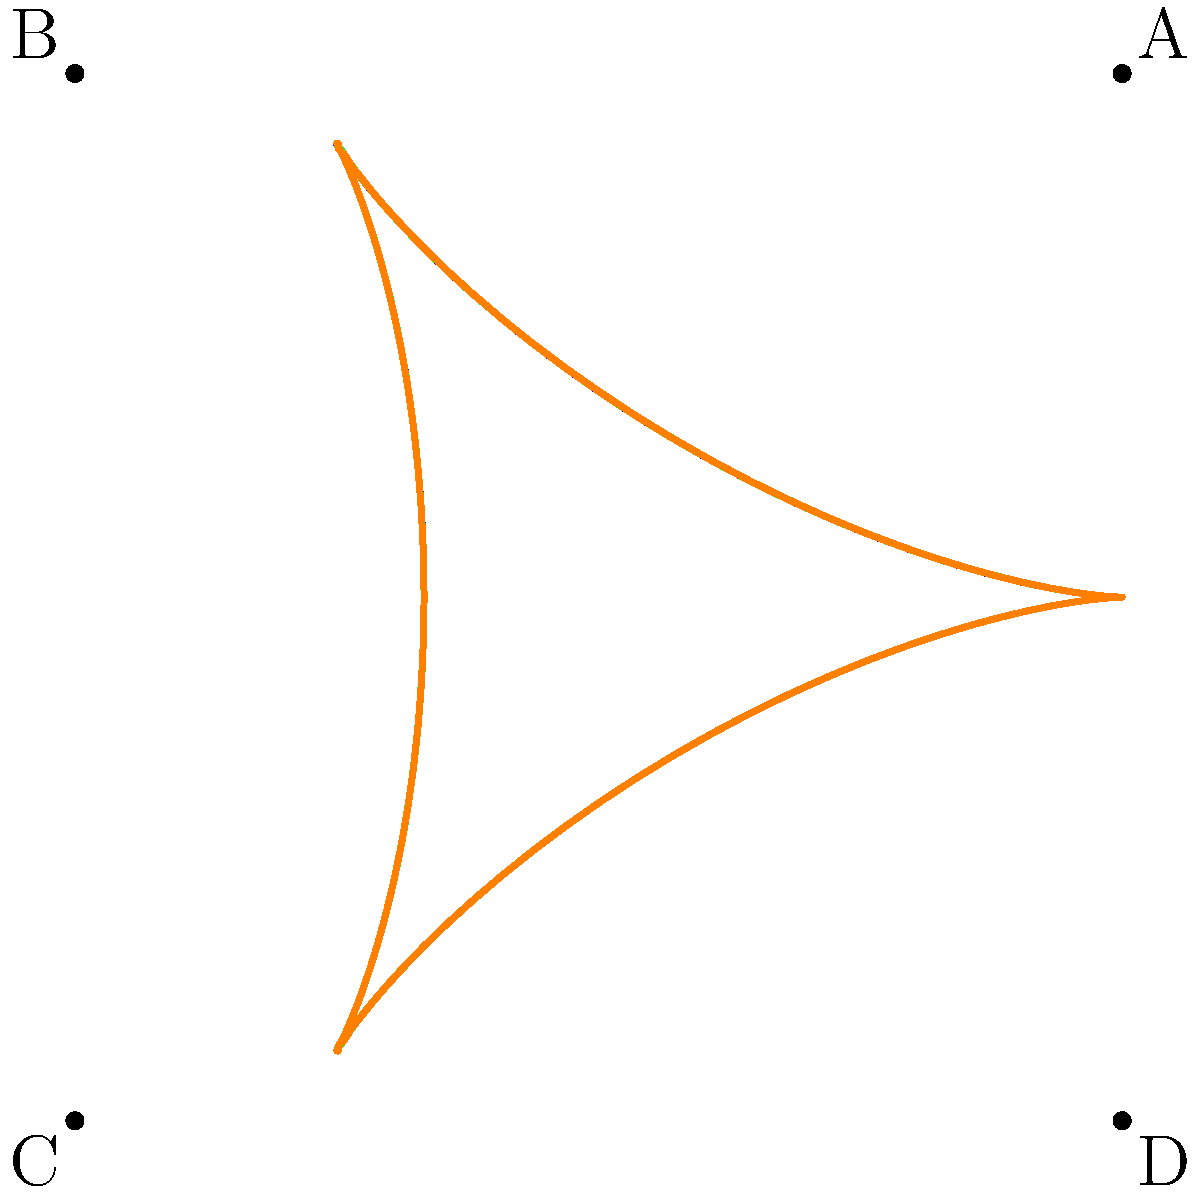In the context of storytelling structures, the diagram above represents different knot types corresponding to narrative patterns. Which point in the diagram would best represent a circular storytelling structure, where the ending connects back to the beginning, much like the way you often bring your daily commute stories full circle? To answer this question, let's analyze the diagram and relate it to storytelling structures:

1. The diagram shows a knot-like structure with four distinct sections, each in a different color.

2. Each section of the knot represents a different storytelling pattern:
   - Linear (straight line): Traditional beginning-middle-end structure
   - Loop (simple closed curve): Circular narrative
   - Figure-eight: Complex, intertwining plot
   - Spiral: Evolving, progressive narrative

3. Looking at the four labeled points (A, B, C, D):
   - Point A: Located at the end of the red section, which forms a loop
   - Point B: At the intersection of blue and green sections
   - Point C: Where the green and orange sections meet
   - Point D: At the end of the orange section, which doesn't close a loop

4. A circular storytelling structure is best represented by a closed loop, where the ending connects seamlessly back to the beginning.

5. Among the given points, only point A is located on a section that forms a complete, closed loop (the red section).

Therefore, point A best represents a circular storytelling structure, mirroring how you bring your daily commute stories full circle.
Answer: A 